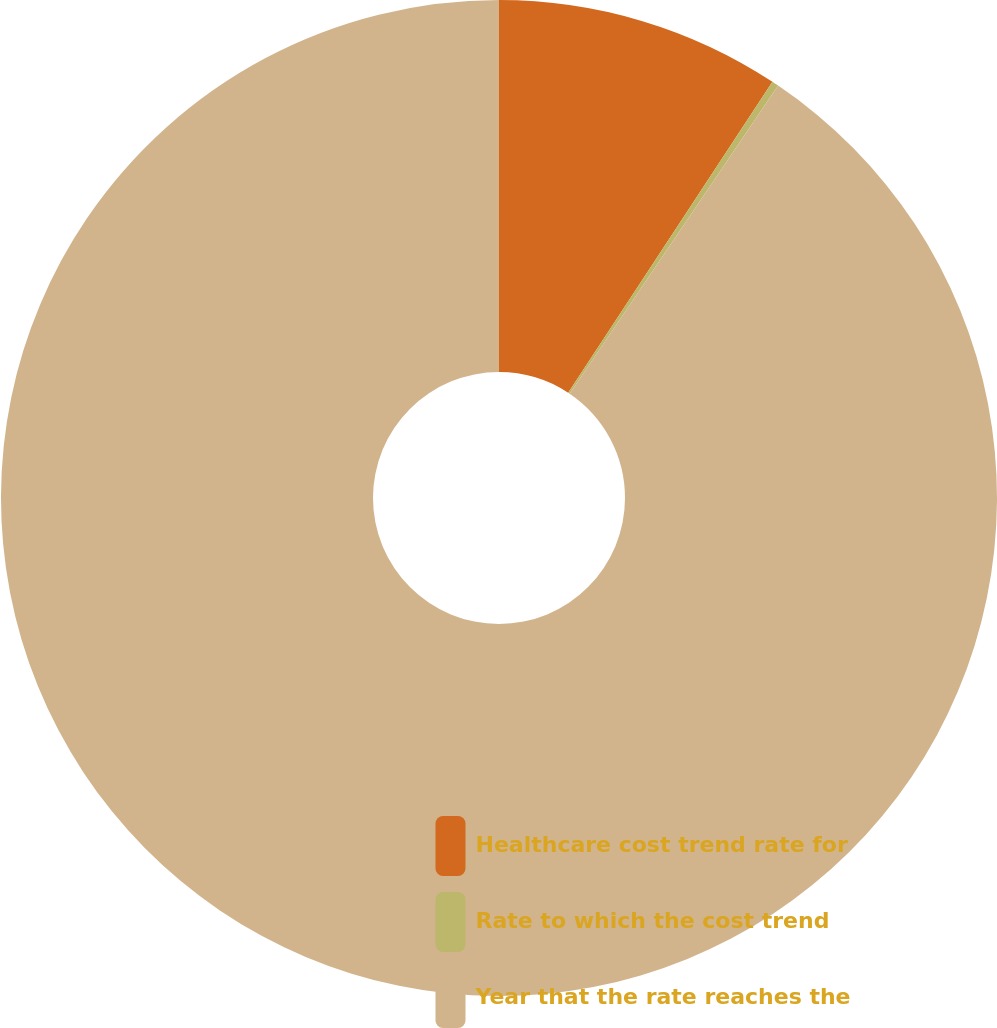Convert chart. <chart><loc_0><loc_0><loc_500><loc_500><pie_chart><fcel>Healthcare cost trend rate for<fcel>Rate to which the cost trend<fcel>Year that the rate reaches the<nl><fcel>9.25%<fcel>0.22%<fcel>90.52%<nl></chart> 